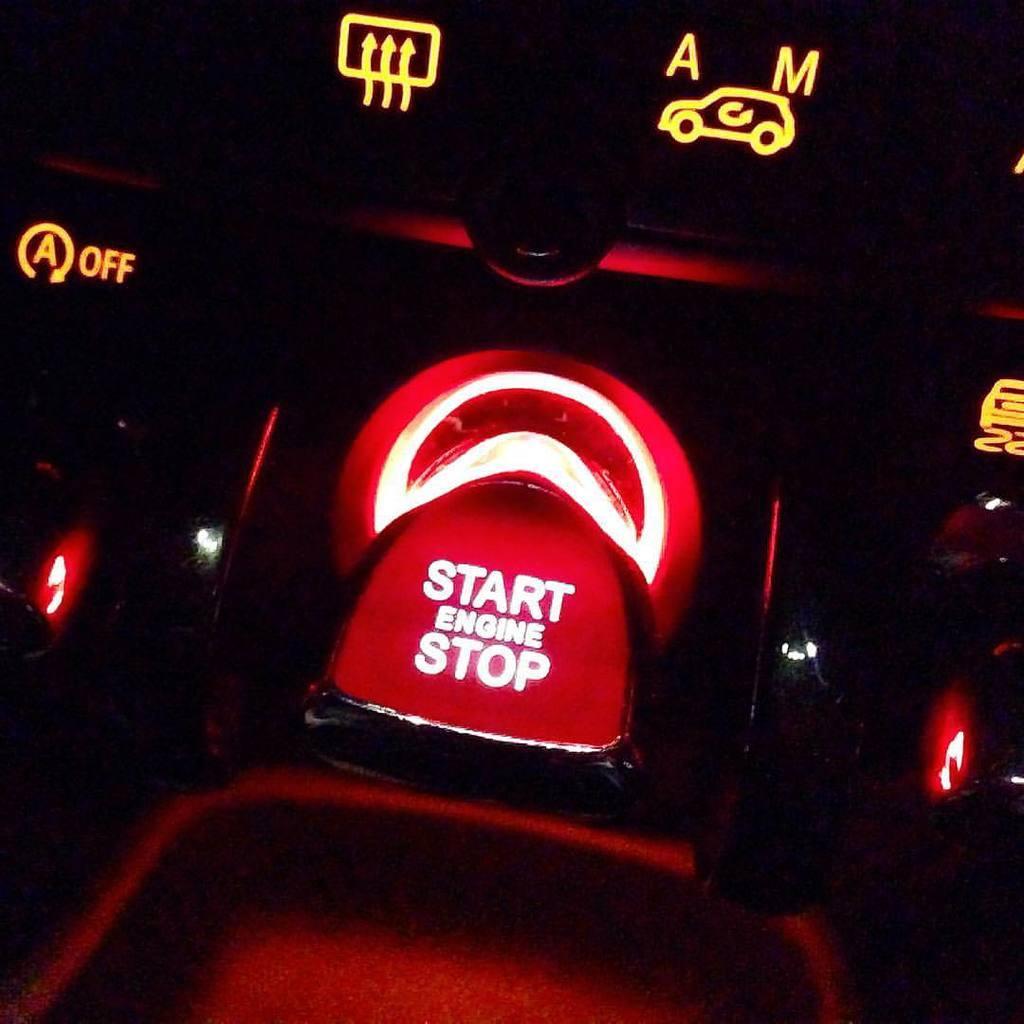Can you describe this image briefly? In this image I can see a start engine stop is written on the red color object. Background is in black color. 